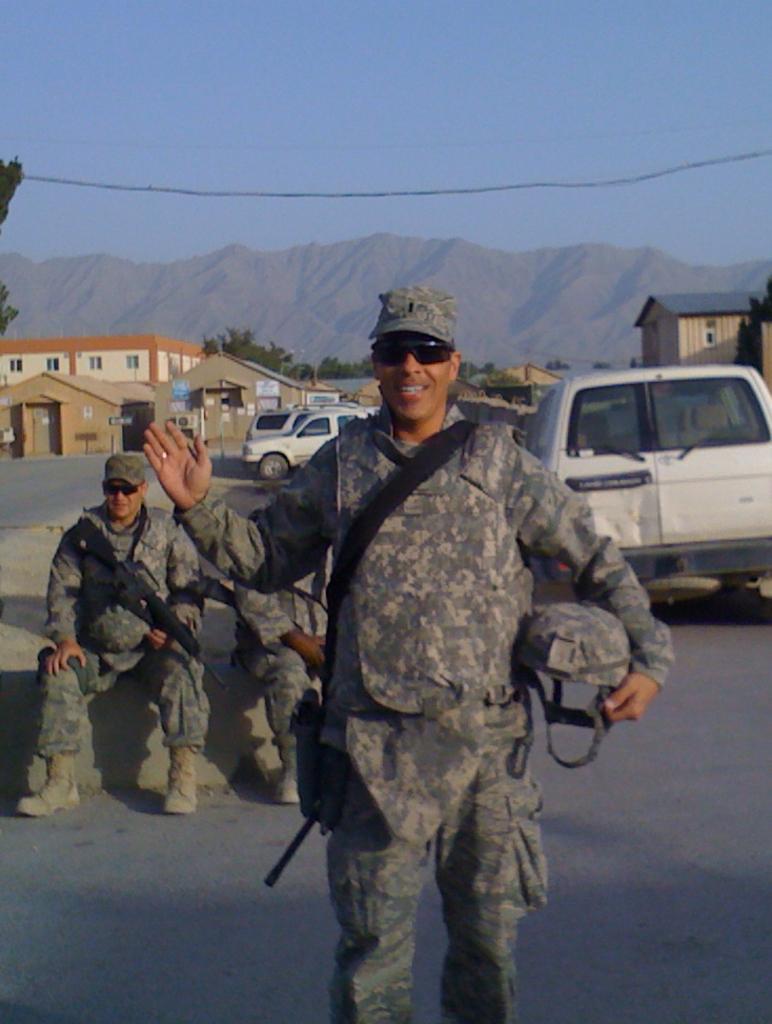In one or two sentences, can you explain what this image depicts? This is the man standing and smiling. He is holding a helmet. I can see two people sitting on the wall. These are the cars, which are parked. I can see the houses and buildings with the windows. These are the trees. In the background, I think these are the mountains. This is the sky. 